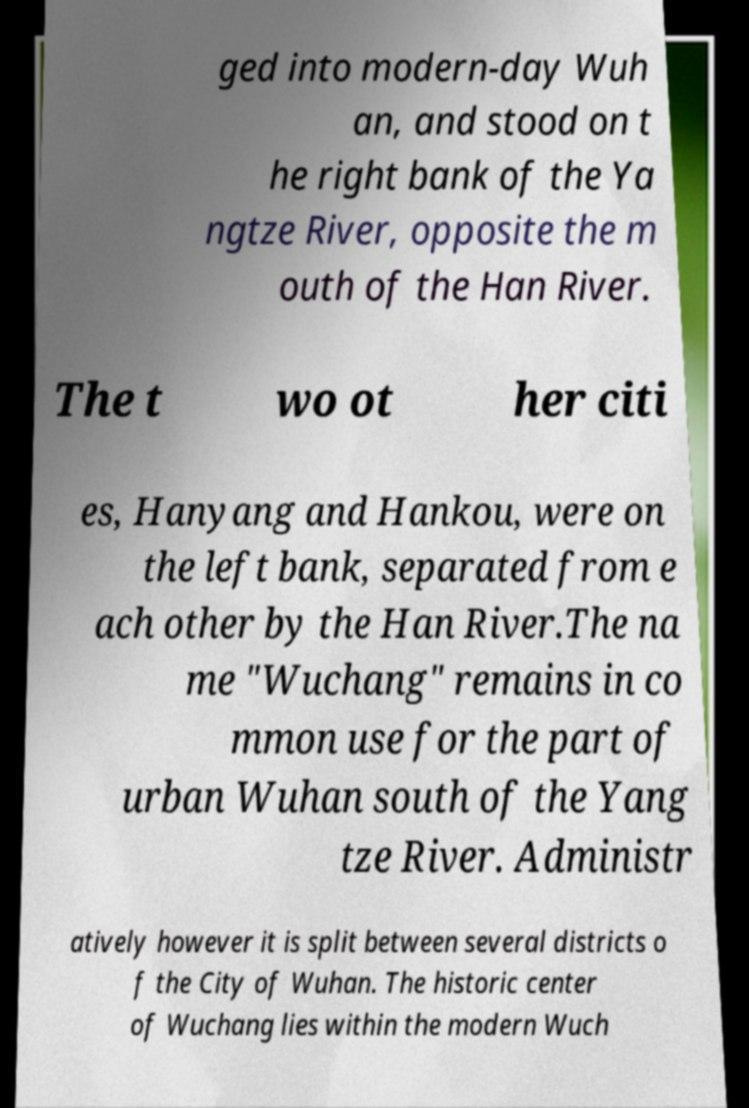Can you read and provide the text displayed in the image?This photo seems to have some interesting text. Can you extract and type it out for me? ged into modern-day Wuh an, and stood on t he right bank of the Ya ngtze River, opposite the m outh of the Han River. The t wo ot her citi es, Hanyang and Hankou, were on the left bank, separated from e ach other by the Han River.The na me "Wuchang" remains in co mmon use for the part of urban Wuhan south of the Yang tze River. Administr atively however it is split between several districts o f the City of Wuhan. The historic center of Wuchang lies within the modern Wuch 